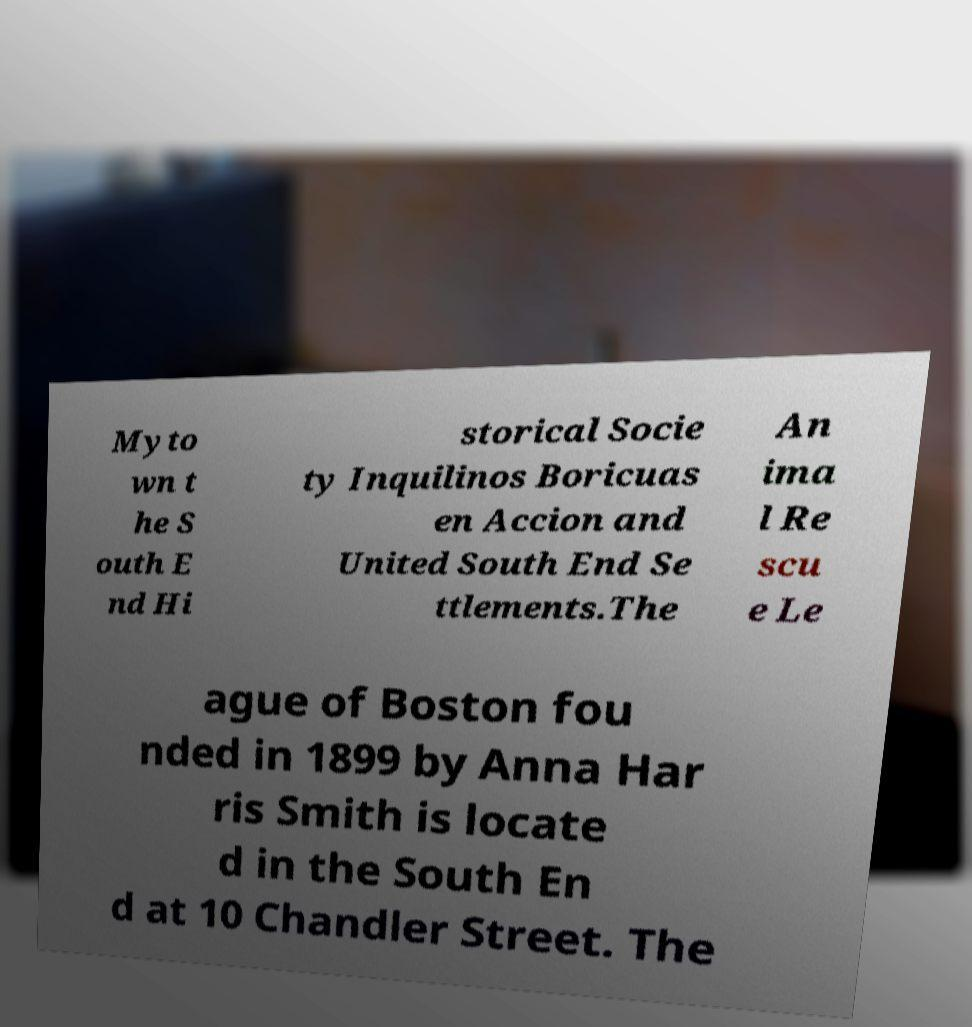Could you extract and type out the text from this image? Myto wn t he S outh E nd Hi storical Socie ty Inquilinos Boricuas en Accion and United South End Se ttlements.The An ima l Re scu e Le ague of Boston fou nded in 1899 by Anna Har ris Smith is locate d in the South En d at 10 Chandler Street. The 